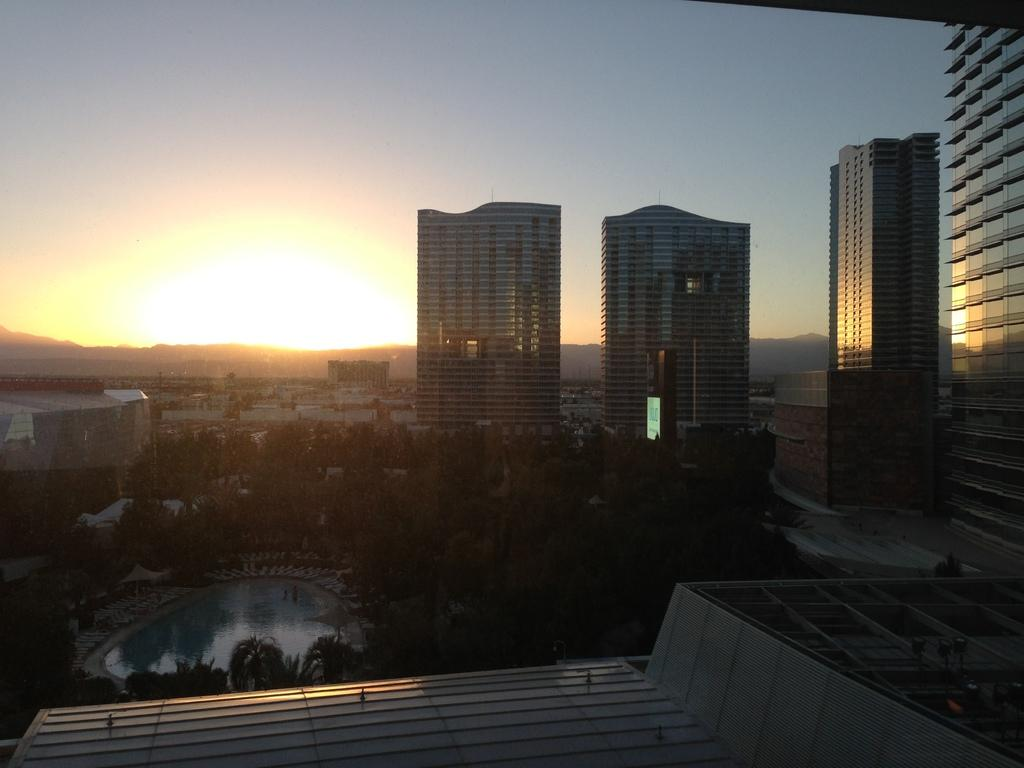What type of structures can be seen in the image? There are buildings in the image. What feature of the buildings is visible in the image? There are windows visible in the image. What type of natural elements can be seen in the image? There are trees and mountains in the image. What type of recreational area is present in the image? There is a swimming pool in the image. What is visible in the sky in the image? The sunset is visible in the image. What is the overall setting of the image? The image features a combination of natural and man-made elements, including buildings, trees, mountains, and a swimming pool. How many beds are visible in the image? There are no beds present in the image. What type of amusement park can be seen in the image? There is no amusement park present in the image. 